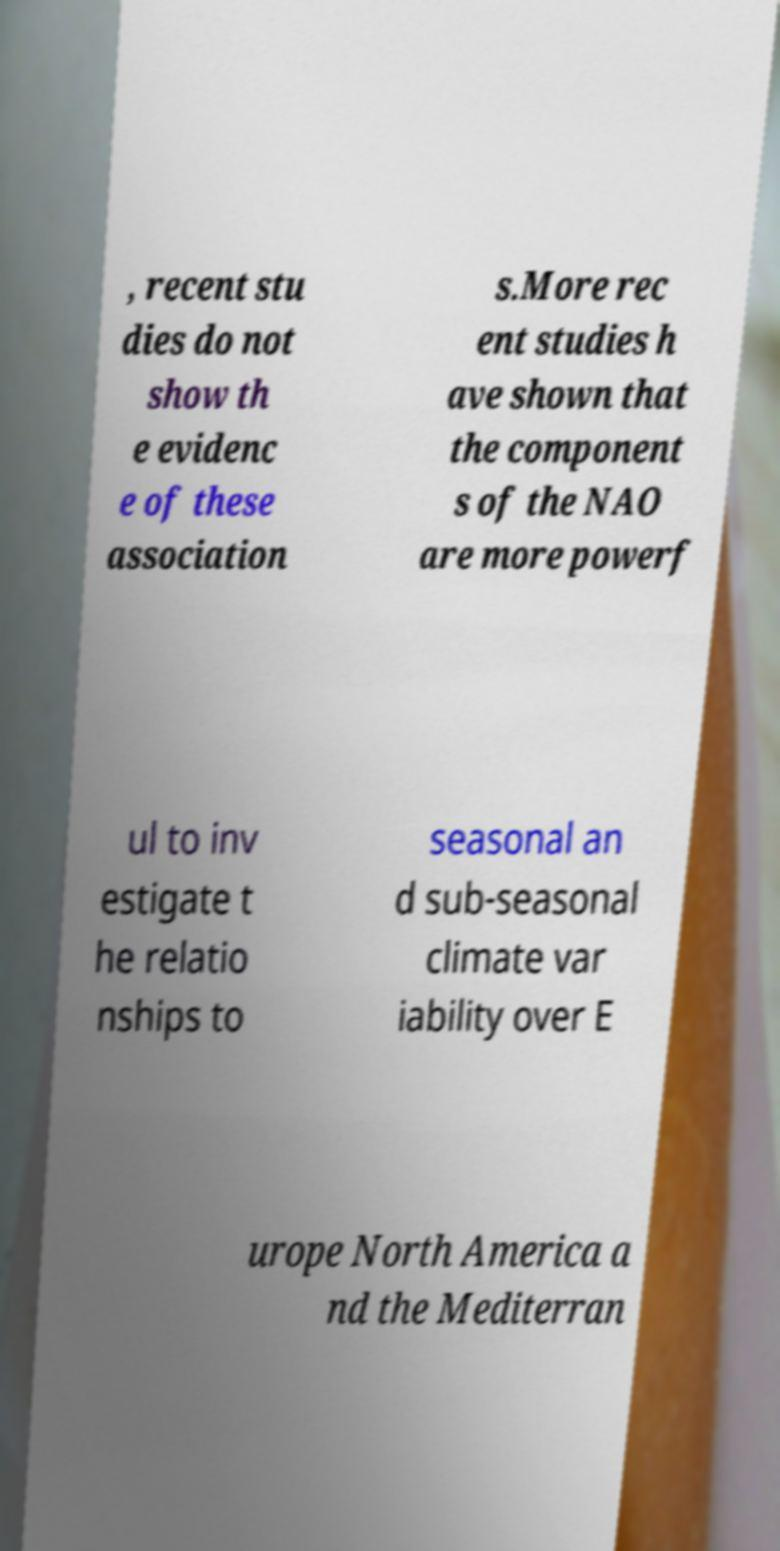For documentation purposes, I need the text within this image transcribed. Could you provide that? , recent stu dies do not show th e evidenc e of these association s.More rec ent studies h ave shown that the component s of the NAO are more powerf ul to inv estigate t he relatio nships to seasonal an d sub-seasonal climate var iability over E urope North America a nd the Mediterran 